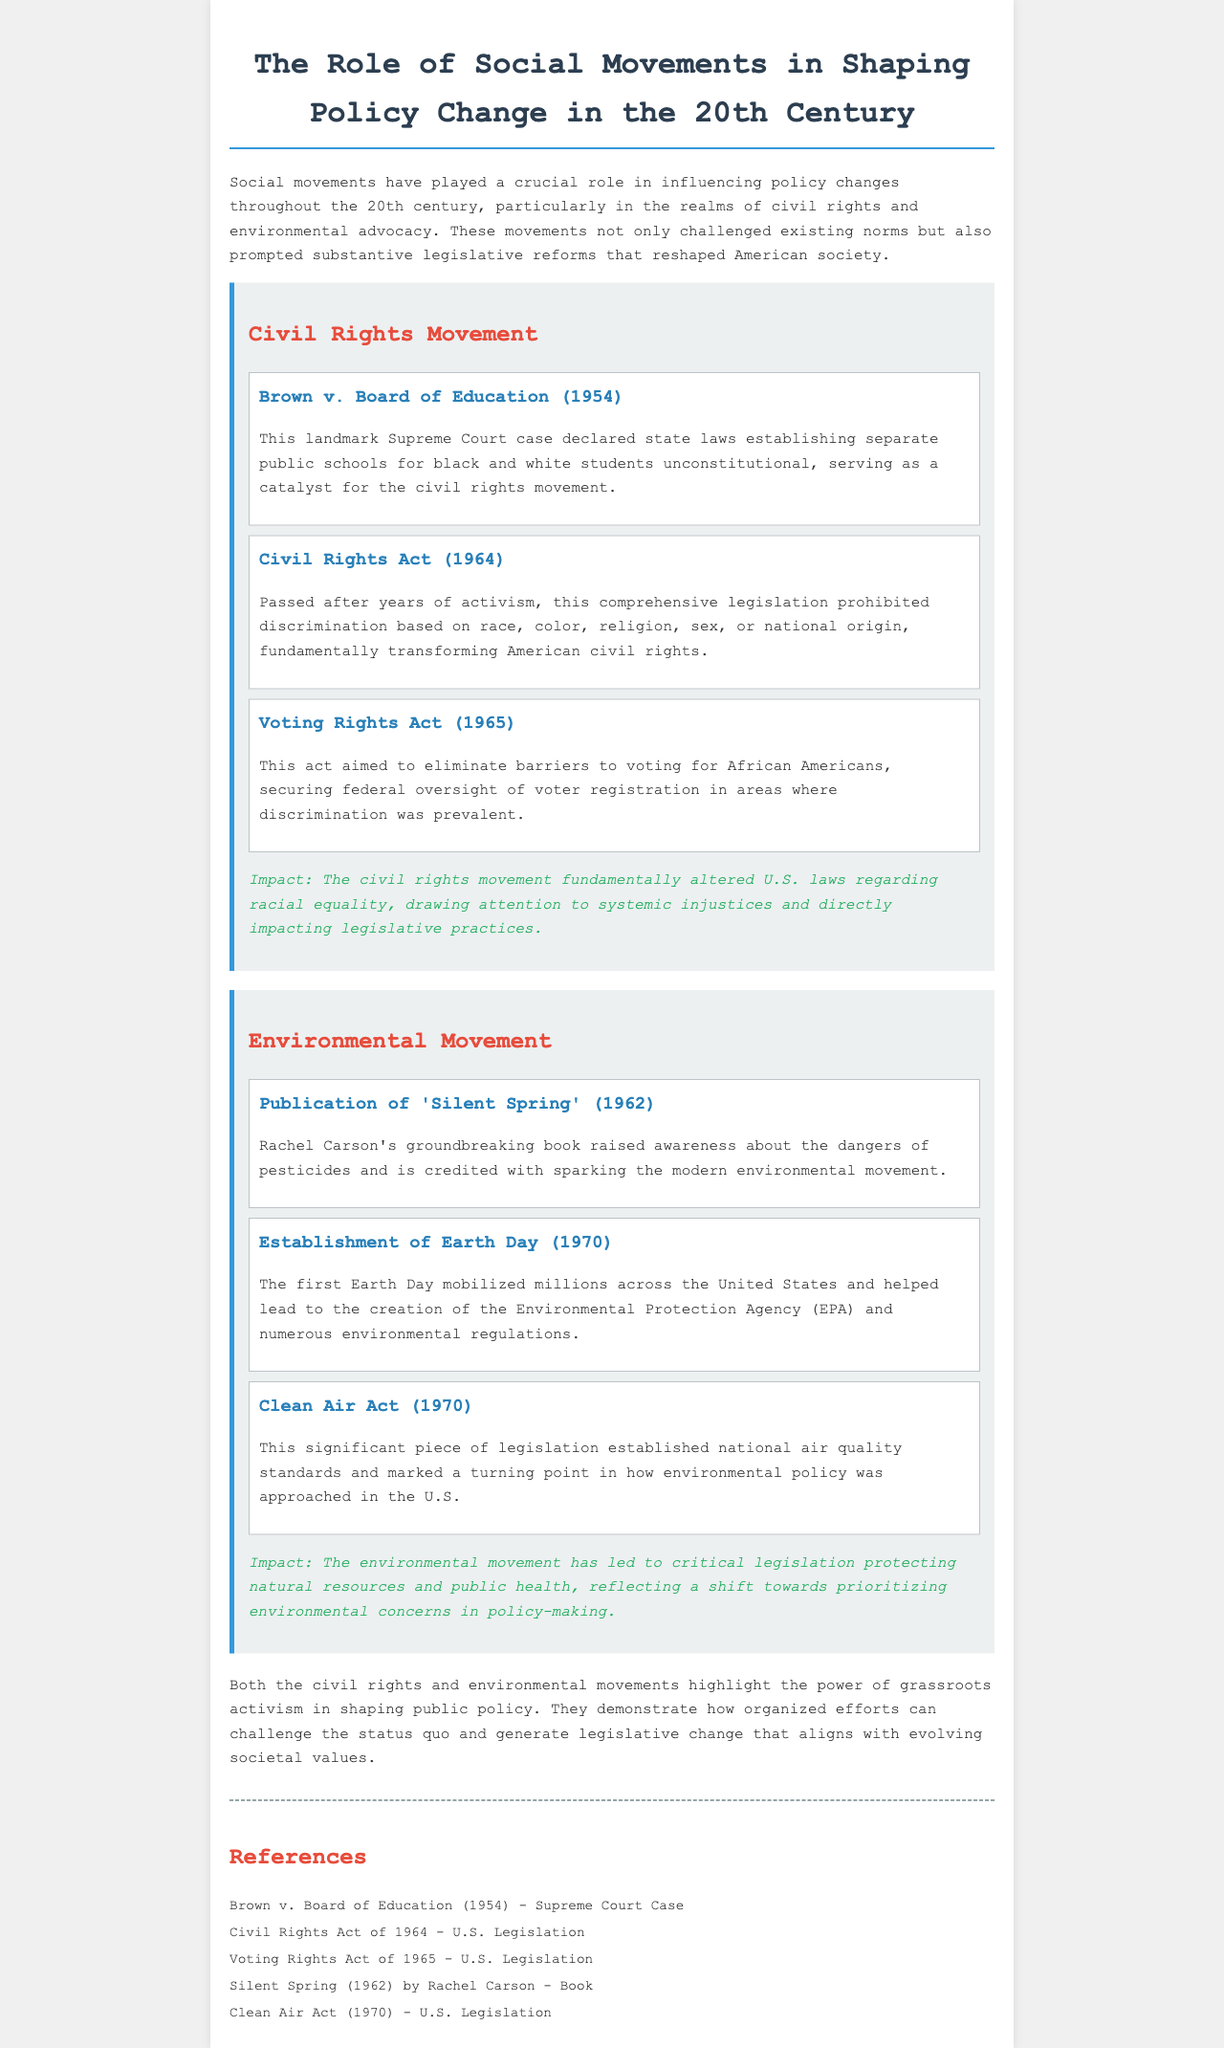what year was the Civil Rights Act passed? The document states that the Civil Rights Act was passed in 1964.
Answer: 1964 what is the title of Rachel Carson's groundbreaking book? The document mentions the title of Rachel Carson's book as 'Silent Spring'.
Answer: 'Silent Spring' what event marked a turning point in environmental policy in the U.S.? The document describes the Clean Air Act (1970) as a significant piece of legislation that established national air quality standards.
Answer: Clean Air Act how did the first Earth Day contribute to environmental policy? According to the document, the first Earth Day led to the creation of the Environmental Protection Agency (EPA) and numerous environmental regulations.
Answer: Creation of the Environmental Protection Agency what was a key impact of the civil rights movement mentioned in the document? The document notes that the civil rights movement fundamentally altered U.S. laws regarding racial equality.
Answer: Altered U.S. laws regarding racial equality what Supreme Court case declared public school segregation unconstitutional? The document states that Brown v. Board of Education (1954) declared state laws establishing separate public schools for black and white students unconstitutional.
Answer: Brown v. Board of Education what year did the Voting Rights Act get enacted? The document states that the Voting Rights Act was enacted in 1965.
Answer: 1965 which event is credited with sparking the modern environmental movement? The document attributes the beginning of the modern environmental movement to the publication of 'Silent Spring' in 1962.
Answer: Publication of 'Silent Spring' what do both the civil rights and environmental movements illustrate about grassroots activism? The document emphasizes that both movements highlight the power of grassroots activism in shaping public policy.
Answer: Power of grassroots activism 